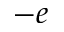<formula> <loc_0><loc_0><loc_500><loc_500>- e</formula> 